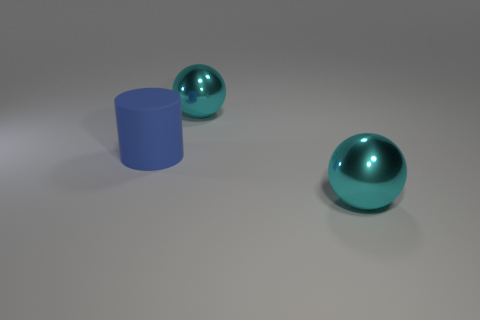Add 1 cyan balls. How many objects exist? 4 Subtract 2 balls. How many balls are left? 0 Subtract 0 cyan cubes. How many objects are left? 3 Subtract all cylinders. How many objects are left? 2 Subtract all yellow balls. Subtract all blue cylinders. How many balls are left? 2 Subtract all large blue cylinders. Subtract all big brown things. How many objects are left? 2 Add 1 large matte things. How many large matte things are left? 2 Add 1 tiny green matte things. How many tiny green matte things exist? 1 